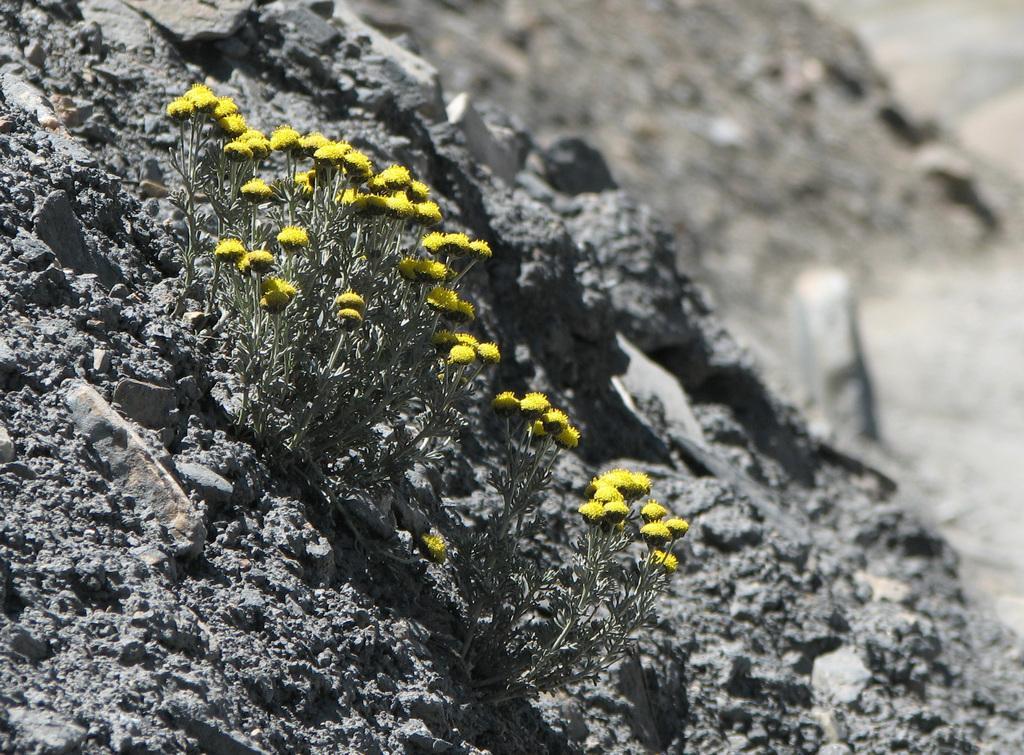In one or two sentences, can you explain what this image depicts? Here we can see small plants with yellow color flowers on the sand. In the background the image is blur but we can see stones on the ground. 